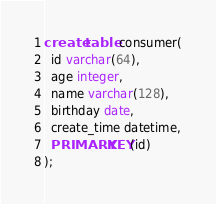<code> <loc_0><loc_0><loc_500><loc_500><_SQL_>create table consumer(
  id varchar(64),
  age integer,
  name varchar(128),
  birthday date,
  create_time datetime,
  PRIMARY KEY(id)
);</code> 